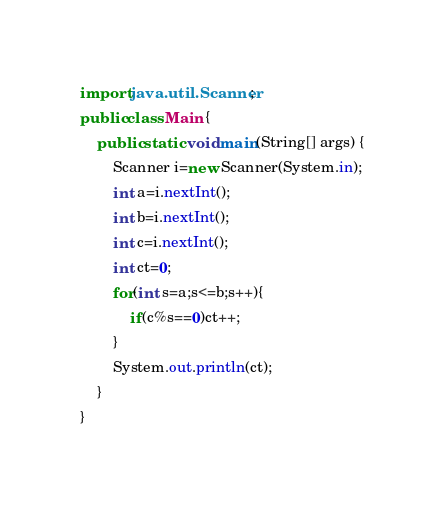Convert code to text. <code><loc_0><loc_0><loc_500><loc_500><_Java_>import java.util.Scanner;
public class Main {
	public static void main(String[] args) {
		Scanner i=new Scanner(System.in);
		int a=i.nextInt();
		int b=i.nextInt();
		int c=i.nextInt();
		int ct=0;
		for(int s=a;s<=b;s++){
			if(c%s==0)ct++;
		}
		System.out.println(ct);
	}
}</code> 